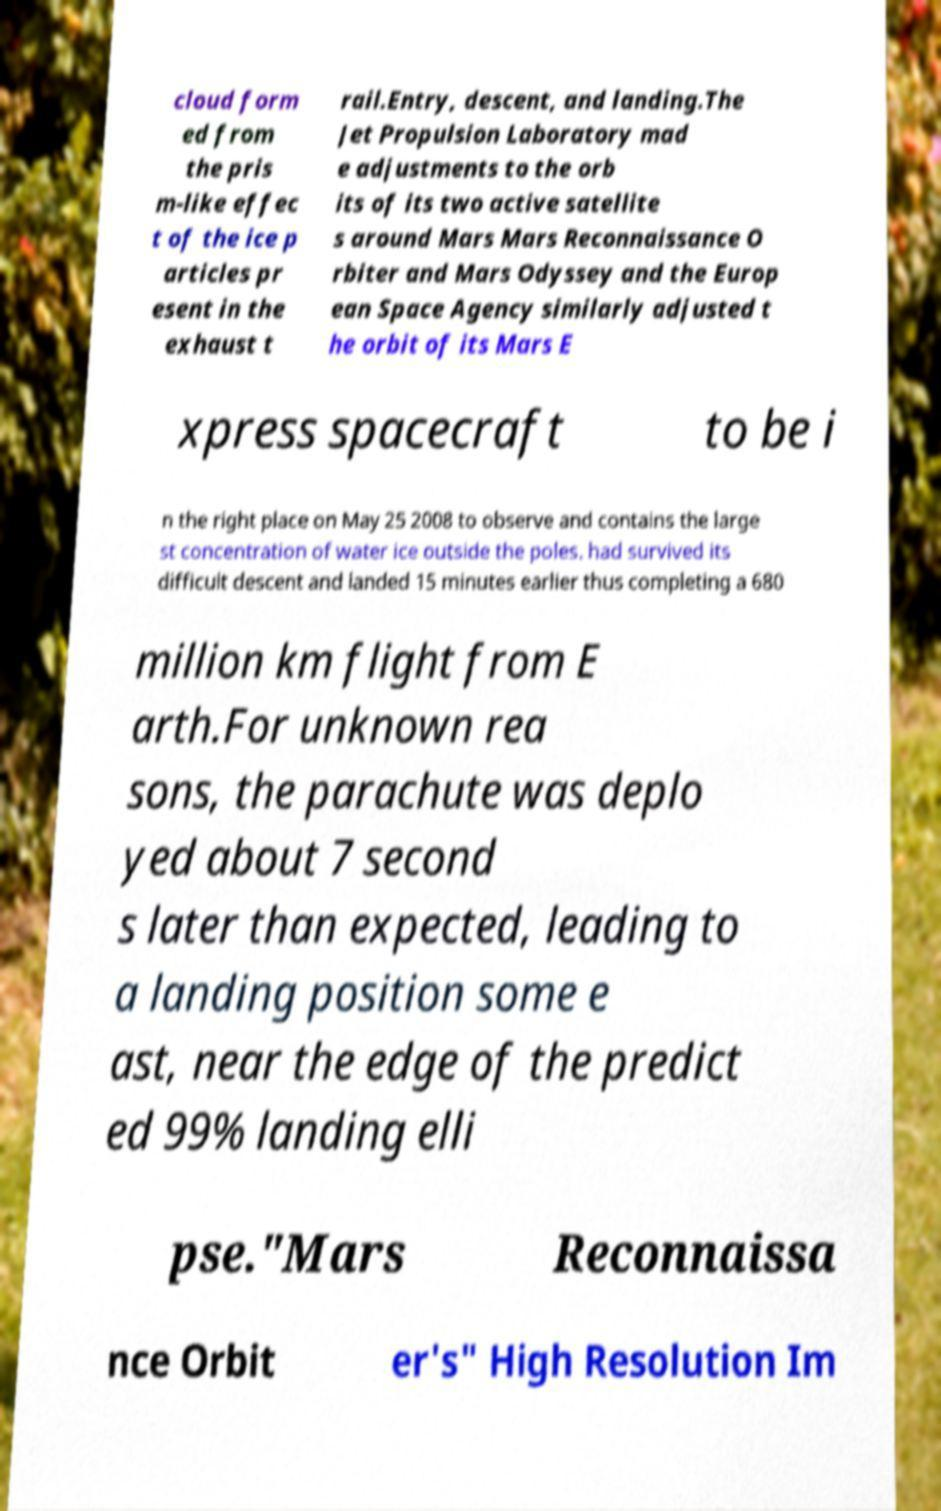Please identify and transcribe the text found in this image. cloud form ed from the pris m-like effec t of the ice p articles pr esent in the exhaust t rail.Entry, descent, and landing.The Jet Propulsion Laboratory mad e adjustments to the orb its of its two active satellite s around Mars Mars Reconnaissance O rbiter and Mars Odyssey and the Europ ean Space Agency similarly adjusted t he orbit of its Mars E xpress spacecraft to be i n the right place on May 25 2008 to observe and contains the large st concentration of water ice outside the poles. had survived its difficult descent and landed 15 minutes earlier thus completing a 680 million km flight from E arth.For unknown rea sons, the parachute was deplo yed about 7 second s later than expected, leading to a landing position some e ast, near the edge of the predict ed 99% landing elli pse."Mars Reconnaissa nce Orbit er's" High Resolution Im 